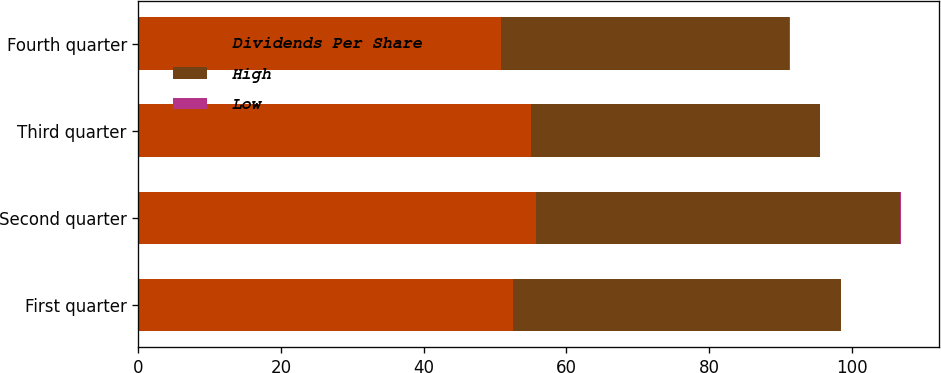<chart> <loc_0><loc_0><loc_500><loc_500><stacked_bar_chart><ecel><fcel>First quarter<fcel>Second quarter<fcel>Third quarter<fcel>Fourth quarter<nl><fcel>Dividends Per Share<fcel>52.52<fcel>55.72<fcel>55.02<fcel>50.86<nl><fcel>High<fcel>45.99<fcel>51.11<fcel>40.52<fcel>40.42<nl><fcel>Low<fcel>0.02<fcel>0.02<fcel>0.03<fcel>0.03<nl></chart> 